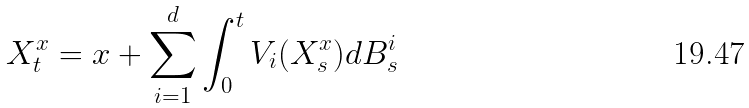<formula> <loc_0><loc_0><loc_500><loc_500>X ^ { x } _ { t } = x + \sum _ { i = 1 } ^ { d } \int _ { 0 } ^ { t } V _ { i } ( X ^ { x } _ { s } ) d B ^ { i } _ { s }</formula> 